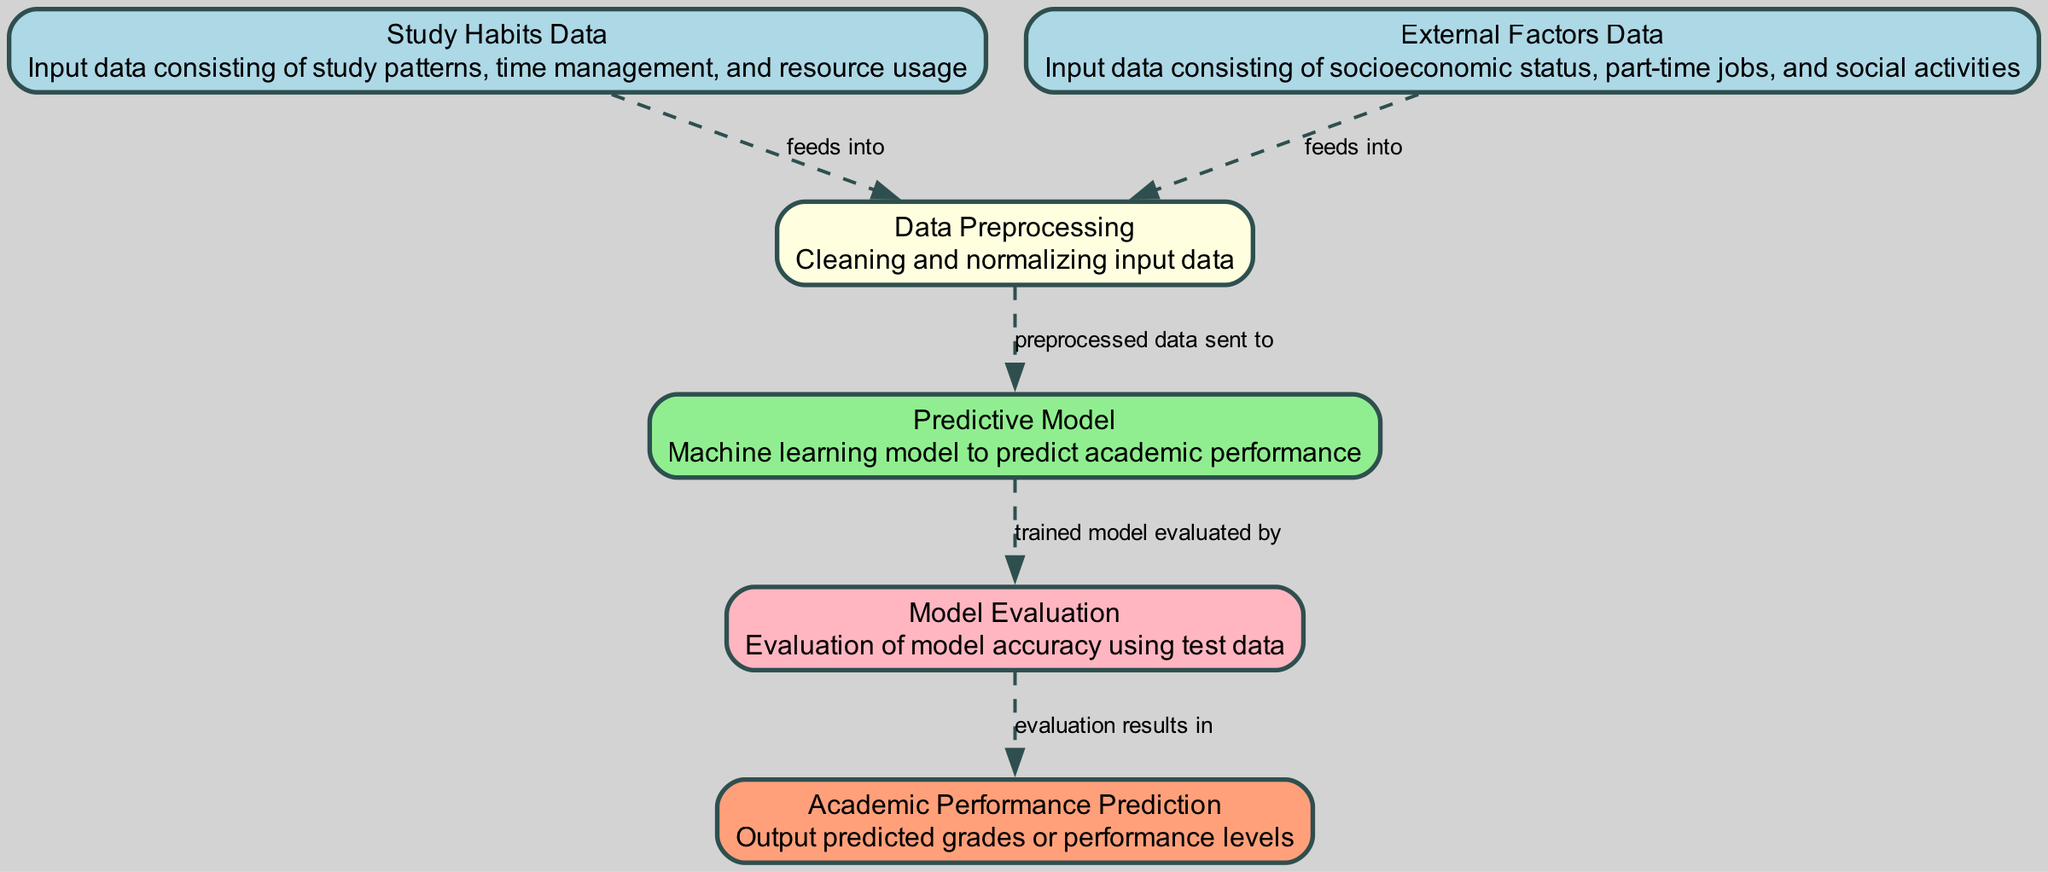What is the first input data type in the diagram? The diagram starts with two input data types, listed as nodes. The first one mentioned is "Study Habits Data."
Answer: Study Habits Data How many nodes are present in the diagram? Counting each unique node shown in the diagram, there are a total of six distinct nodes.
Answer: 6 What type of data is used to inform the "Predictive Model"? The "Predictive Model" receives data after it has been cleaned and normalized, which comes from the "Data Preprocessing" node.
Answer: Preprocessed data Which nodes are connected to the "Data Preprocessing" node? The "Data Preprocessing" node is connected to two input nodes: "Study Habits Data" and "External Factors Data."
Answer: Study Habits Data and External Factors Data What does the "Model Evaluation" node lead to? The "Model Evaluation" node has a direct relationship to the next node it outputs to, which is the "Academic Performance Prediction" node.
Answer: Academic Performance Prediction Why is data preprocessed before being sent to the model? Preprocessing is crucial to ensure the input data is clean and normalized, removing inconsistencies that could affect the model's accuracy when making predictions.
Answer: To ensure data quality What is the purpose of the "Evaluation" node in the diagram? The "Evaluation" node's purpose is to assess the accuracy of the predictive model using test data, which reflects its effectiveness.
Answer: To assess accuracy What color represents the "Predictive Model" node? Each node in the diagram has a designated color for easy identification. The "Predictive Model" node is represented in light green.
Answer: Light green What type of relationship is indicated between the "Model" and the "Evaluation" nodes? The relationship between these two nodes is foundational, where the trained model is evaluated by the evaluation node, which is indicated by a dashed edge labeled as "trained model evaluated by."
Answer: Trained model evaluated by 